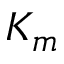Convert formula to latex. <formula><loc_0><loc_0><loc_500><loc_500>K _ { m }</formula> 